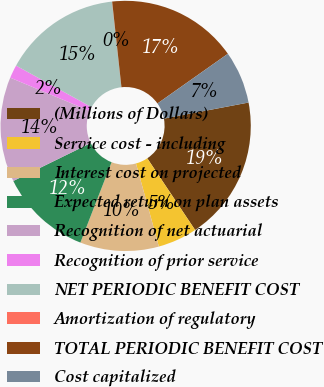Convert chart. <chart><loc_0><loc_0><loc_500><loc_500><pie_chart><fcel>(Millions of Dollars)<fcel>Service cost - including<fcel>Interest cost on projected<fcel>Expected return on plan assets<fcel>Recognition of net actuarial<fcel>Recognition of prior service<fcel>NET PERIODIC BENEFIT COST<fcel>Amortization of regulatory<fcel>TOTAL PERIODIC BENEFIT COST<fcel>Cost capitalized<nl><fcel>18.63%<fcel>5.09%<fcel>10.17%<fcel>11.86%<fcel>13.55%<fcel>1.71%<fcel>15.25%<fcel>0.02%<fcel>16.94%<fcel>6.79%<nl></chart> 